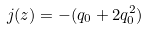Convert formula to latex. <formula><loc_0><loc_0><loc_500><loc_500>j ( z ) = - ( q _ { 0 } + 2 q _ { 0 } ^ { 2 } )</formula> 